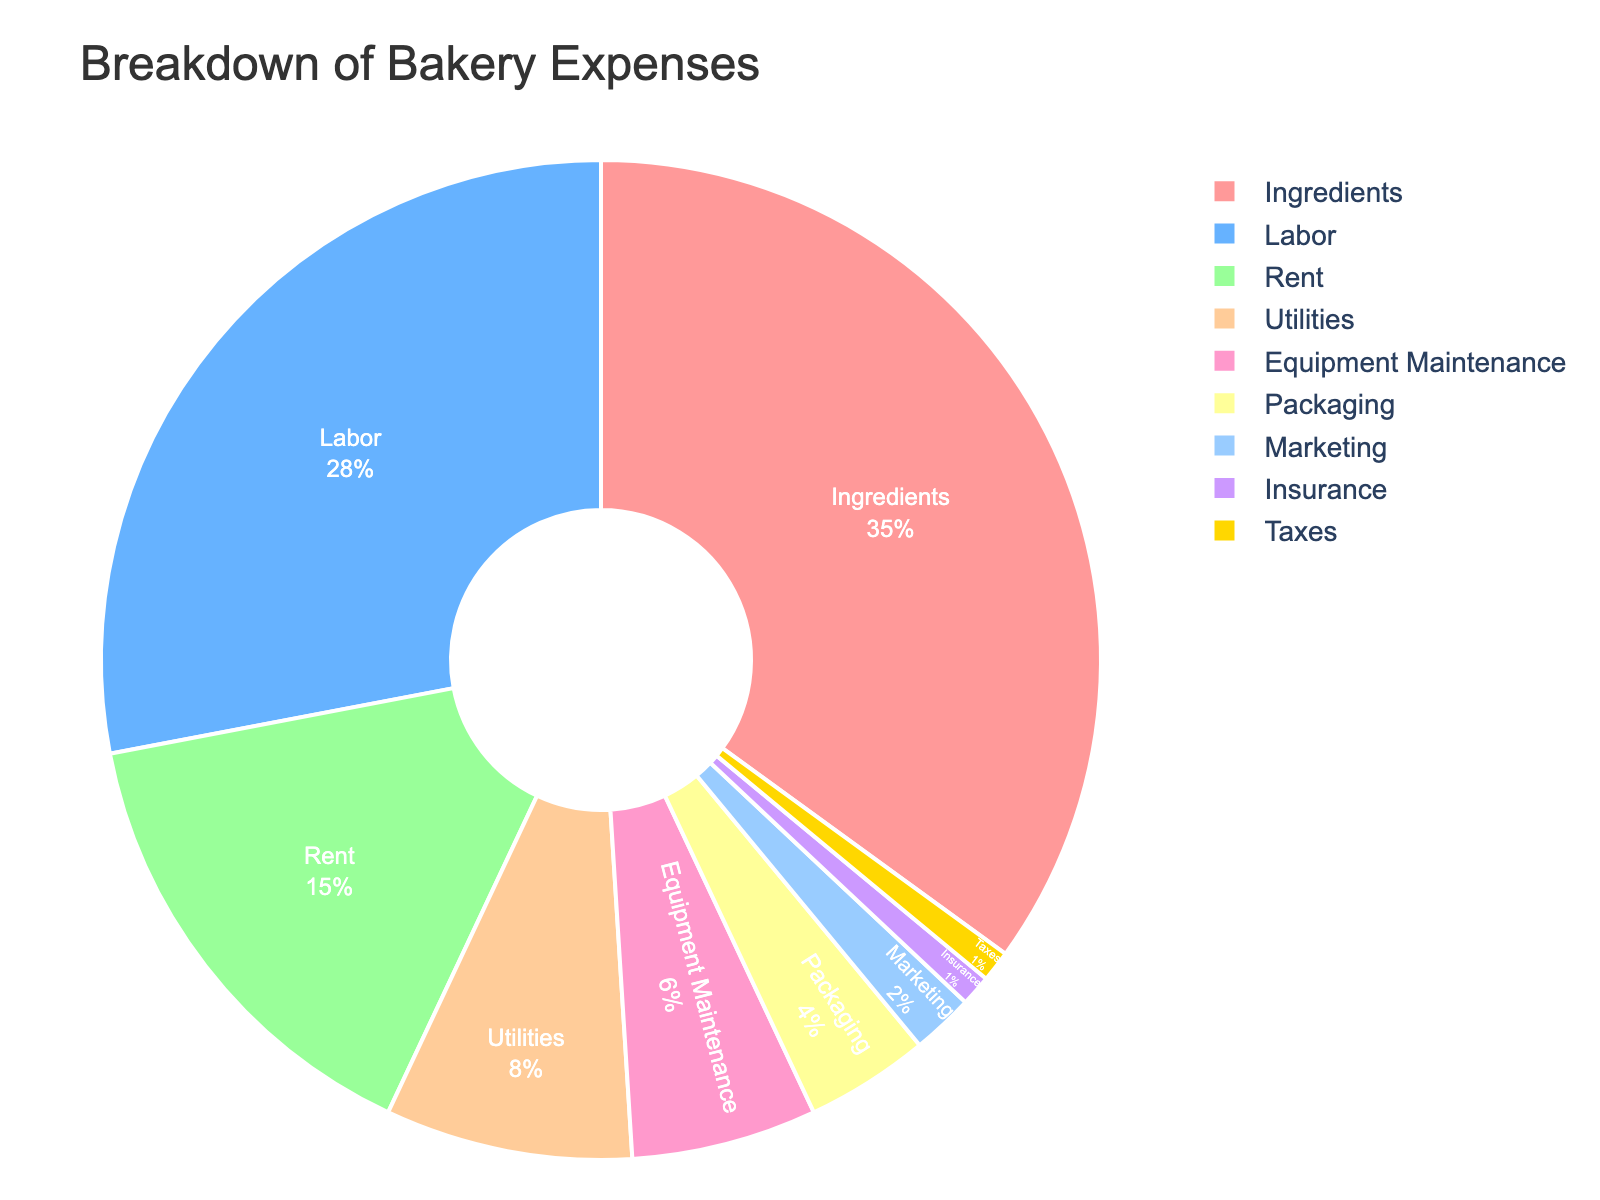Which category has the largest expense? By looking at the pie chart, it is clear that the category with the largest expense has the biggest proportion of the pie. Ingredients take up 35% of the pie, which is the largest segment.
Answer: Ingredients What percentage of total expenses is spent on labor and rent together? To find this, add the percentage of expenses spent on labor (28%) and rent (15%). So, 28 + 15 = 43%.
Answer: 43% Is the expense on taxes more than the expense on marketing? In the pie chart, marketing is 2% while taxes are 1%. Comparing these two values, marketing (2%) is greater than taxes (1%).
Answer: No What is the difference in percentage between the expenses on equipment maintenance and packaging? Look at the figures for equipment maintenance (6%) and packaging (4%). The difference is 6 - 4 = 2%.
Answer: 2% Which categories have expenses less than 5%? Check each segment to see which ones are less than 5%. Packaging (4%), Marketing (2%), Insurance (1%), and Taxes (1%) all fall under 5%.
Answer: Packaging, Marketing, Insurance, and Taxes What is the combined percentage of all categories with less than 10% expense? Find the percentages for categories with expenses less than 10%: Utilities (8%), Equipment Maintenance (6%), Packaging (4%), Marketing (2%), Insurance (1%), and Taxes (1%). Their combined percentage is 8 + 6 + 4 + 2 + 1 + 1 = 22%.
Answer: 22% Which category has the smallest expense, and what is its percentage? By looking at the smallest segment in the pie chart, we can identify that both Insurance and Taxes are the smallest categories at 1% each.
Answer: Insurance and Taxes, 1% How much more percentage is spent on ingredients compared to utilities? Check the figures for ingredients (35%) and utilities (8%) and find the difference. 35 - 8 = 27%.
Answer: 27% Is the expenditure on labor higher, lower, or equal to the expenditure on rent plus utilities? Labor is 28% and rent plus utilities is 15 + 8 = 23%. Comparing these two values, labor (28%) is higher than rent plus utilities (23%).
Answer: Higher 